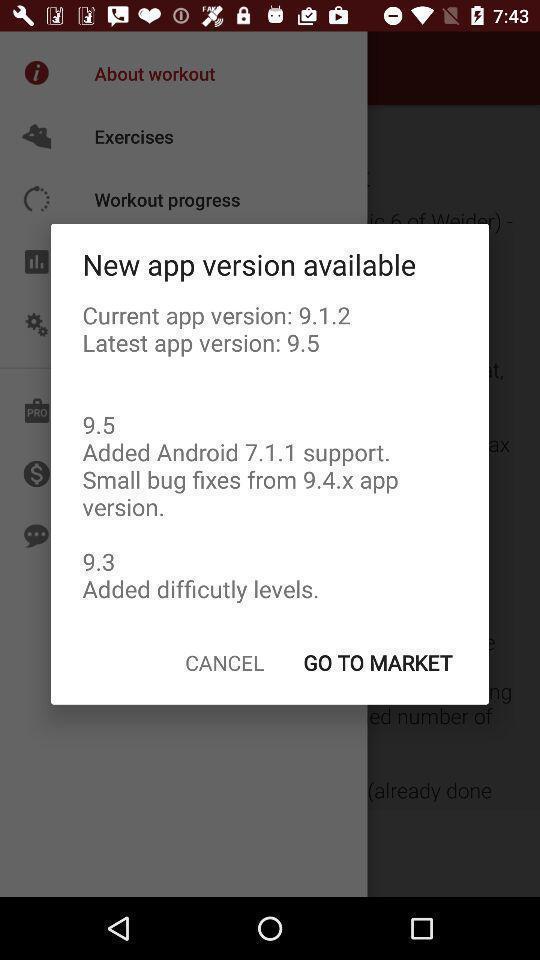Tell me about the visual elements in this screen capture. Popup page displaying description of new version. 